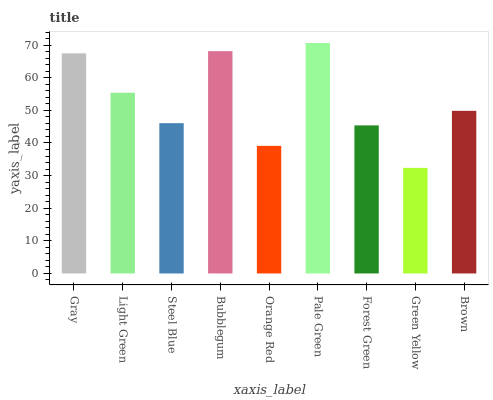Is Green Yellow the minimum?
Answer yes or no. Yes. Is Pale Green the maximum?
Answer yes or no. Yes. Is Light Green the minimum?
Answer yes or no. No. Is Light Green the maximum?
Answer yes or no. No. Is Gray greater than Light Green?
Answer yes or no. Yes. Is Light Green less than Gray?
Answer yes or no. Yes. Is Light Green greater than Gray?
Answer yes or no. No. Is Gray less than Light Green?
Answer yes or no. No. Is Brown the high median?
Answer yes or no. Yes. Is Brown the low median?
Answer yes or no. Yes. Is Steel Blue the high median?
Answer yes or no. No. Is Steel Blue the low median?
Answer yes or no. No. 